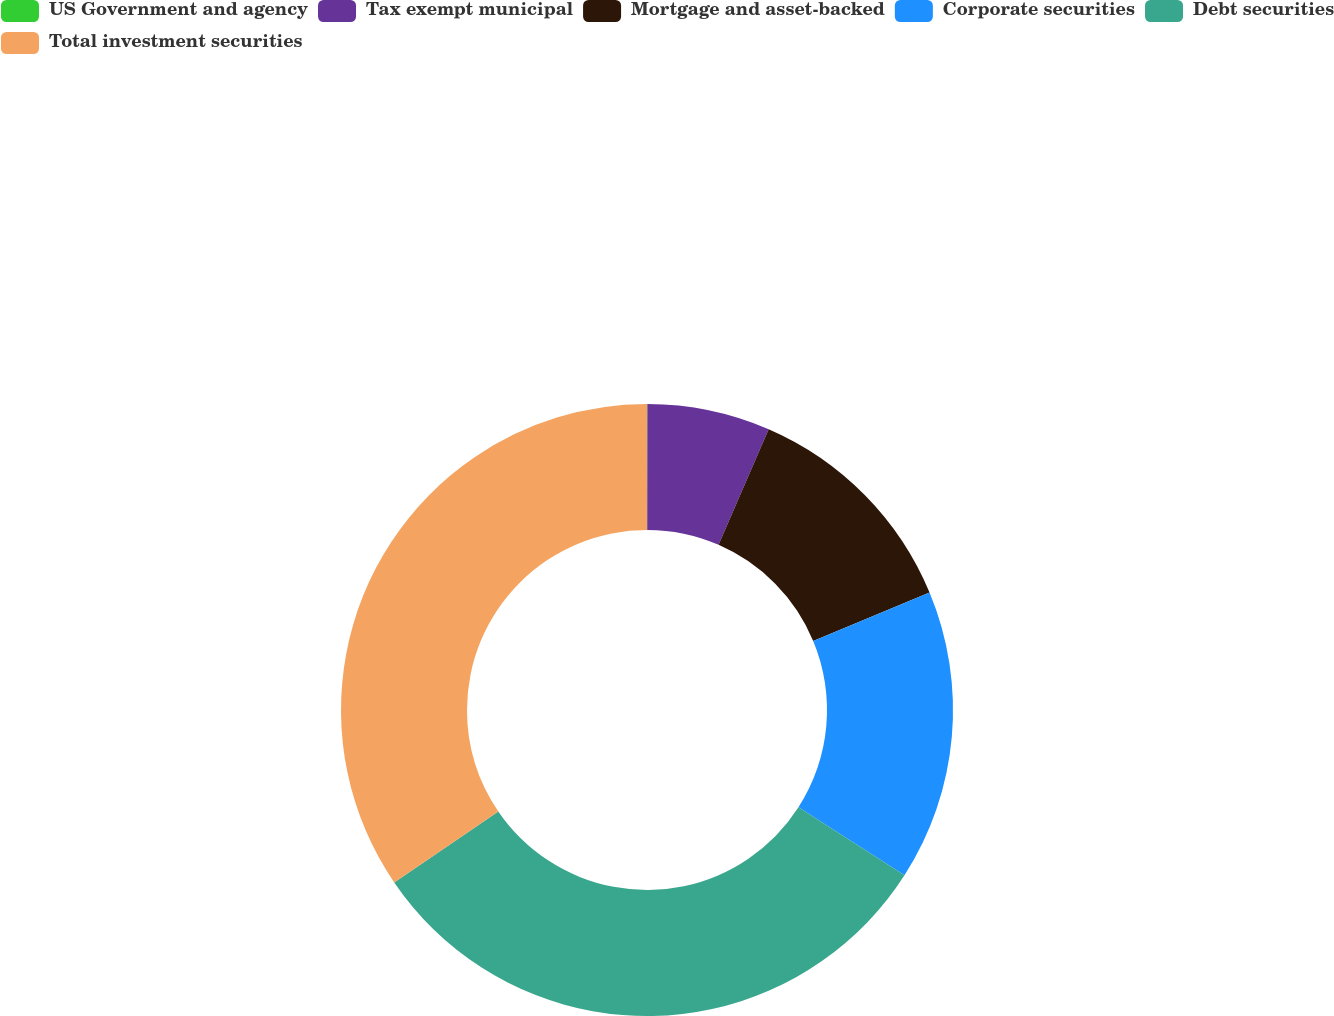Convert chart to OTSL. <chart><loc_0><loc_0><loc_500><loc_500><pie_chart><fcel>US Government and agency<fcel>Tax exempt municipal<fcel>Mortgage and asset-backed<fcel>Corporate securities<fcel>Debt securities<fcel>Total investment securities<nl><fcel>0.02%<fcel>6.49%<fcel>12.22%<fcel>15.36%<fcel>31.39%<fcel>34.53%<nl></chart> 